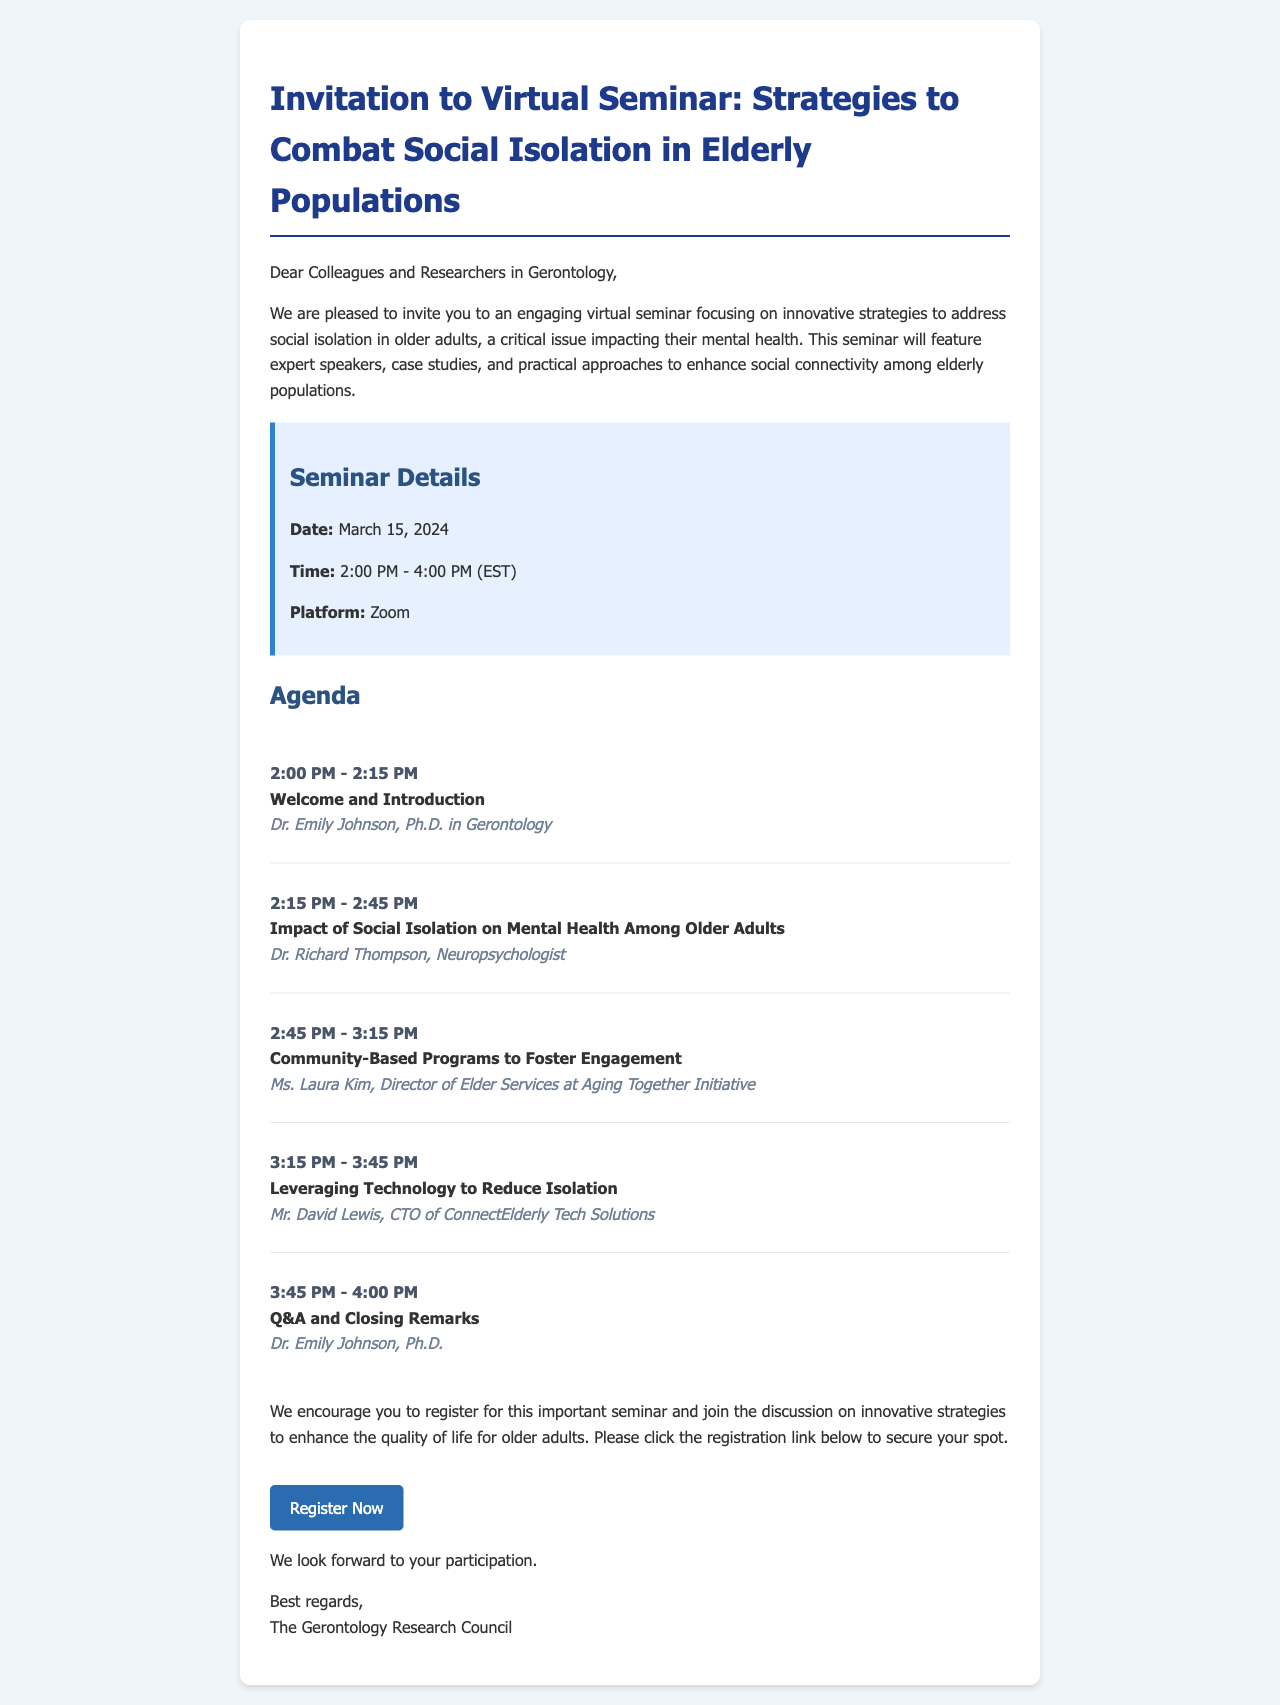What is the date of the seminar? The date of the seminar is clearly stated in the details section of the document.
Answer: March 15, 2024 Who is the speaker for the introduction? The speaker for the introduction is mentioned in the agenda section of the document.
Answer: Dr. Emily Johnson, Ph.D. in Gerontology What is the time duration for the seminar? The time duration is specified in the seminar details as the period between the start and end times.
Answer: 2 hours What topic is covered from 2:15 PM to 2:45 PM? The topic during this time is outlined in the agenda section of the document.
Answer: Impact of Social Isolation on Mental Health Among Older Adults What is the registration link for the seminar? The registration link is provided at the end of the invitation, allowing attendees to sign up for the seminar.
Answer: https://www.gerontologyresearch.org/webinar-registration How many agenda items are listed in the document? The number of agenda items is derived from the bullet points in the agenda section.
Answer: 5 What will happen during the last segment of the seminar? The last segment details what will occur at the end of the seminar in the agenda section.
Answer: Q&A and Closing Remarks What organization is hosting the seminar? The hosting organization is mentioned at the end of the document in the closing remarks.
Answer: The Gerontology Research Council 